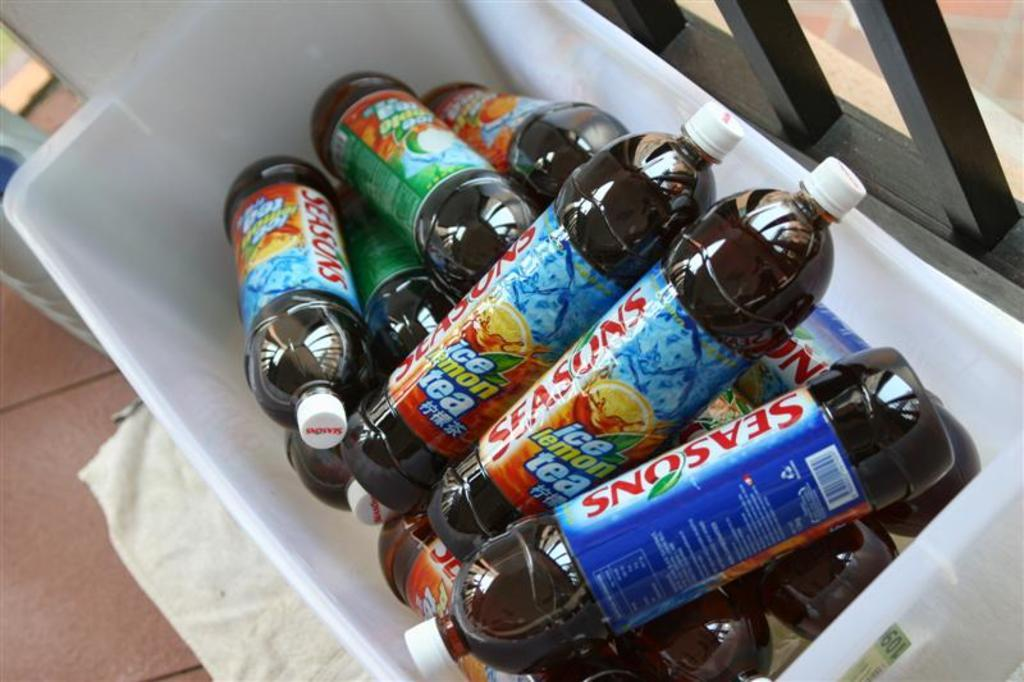Provide a one-sentence caption for the provided image. A number of bottles of soft drink called Seasons in a white plastic container. 